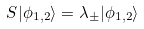<formula> <loc_0><loc_0><loc_500><loc_500>S | \phi _ { 1 , 2 } \rangle = \lambda _ { \pm } | \phi _ { 1 , 2 } \rangle</formula> 